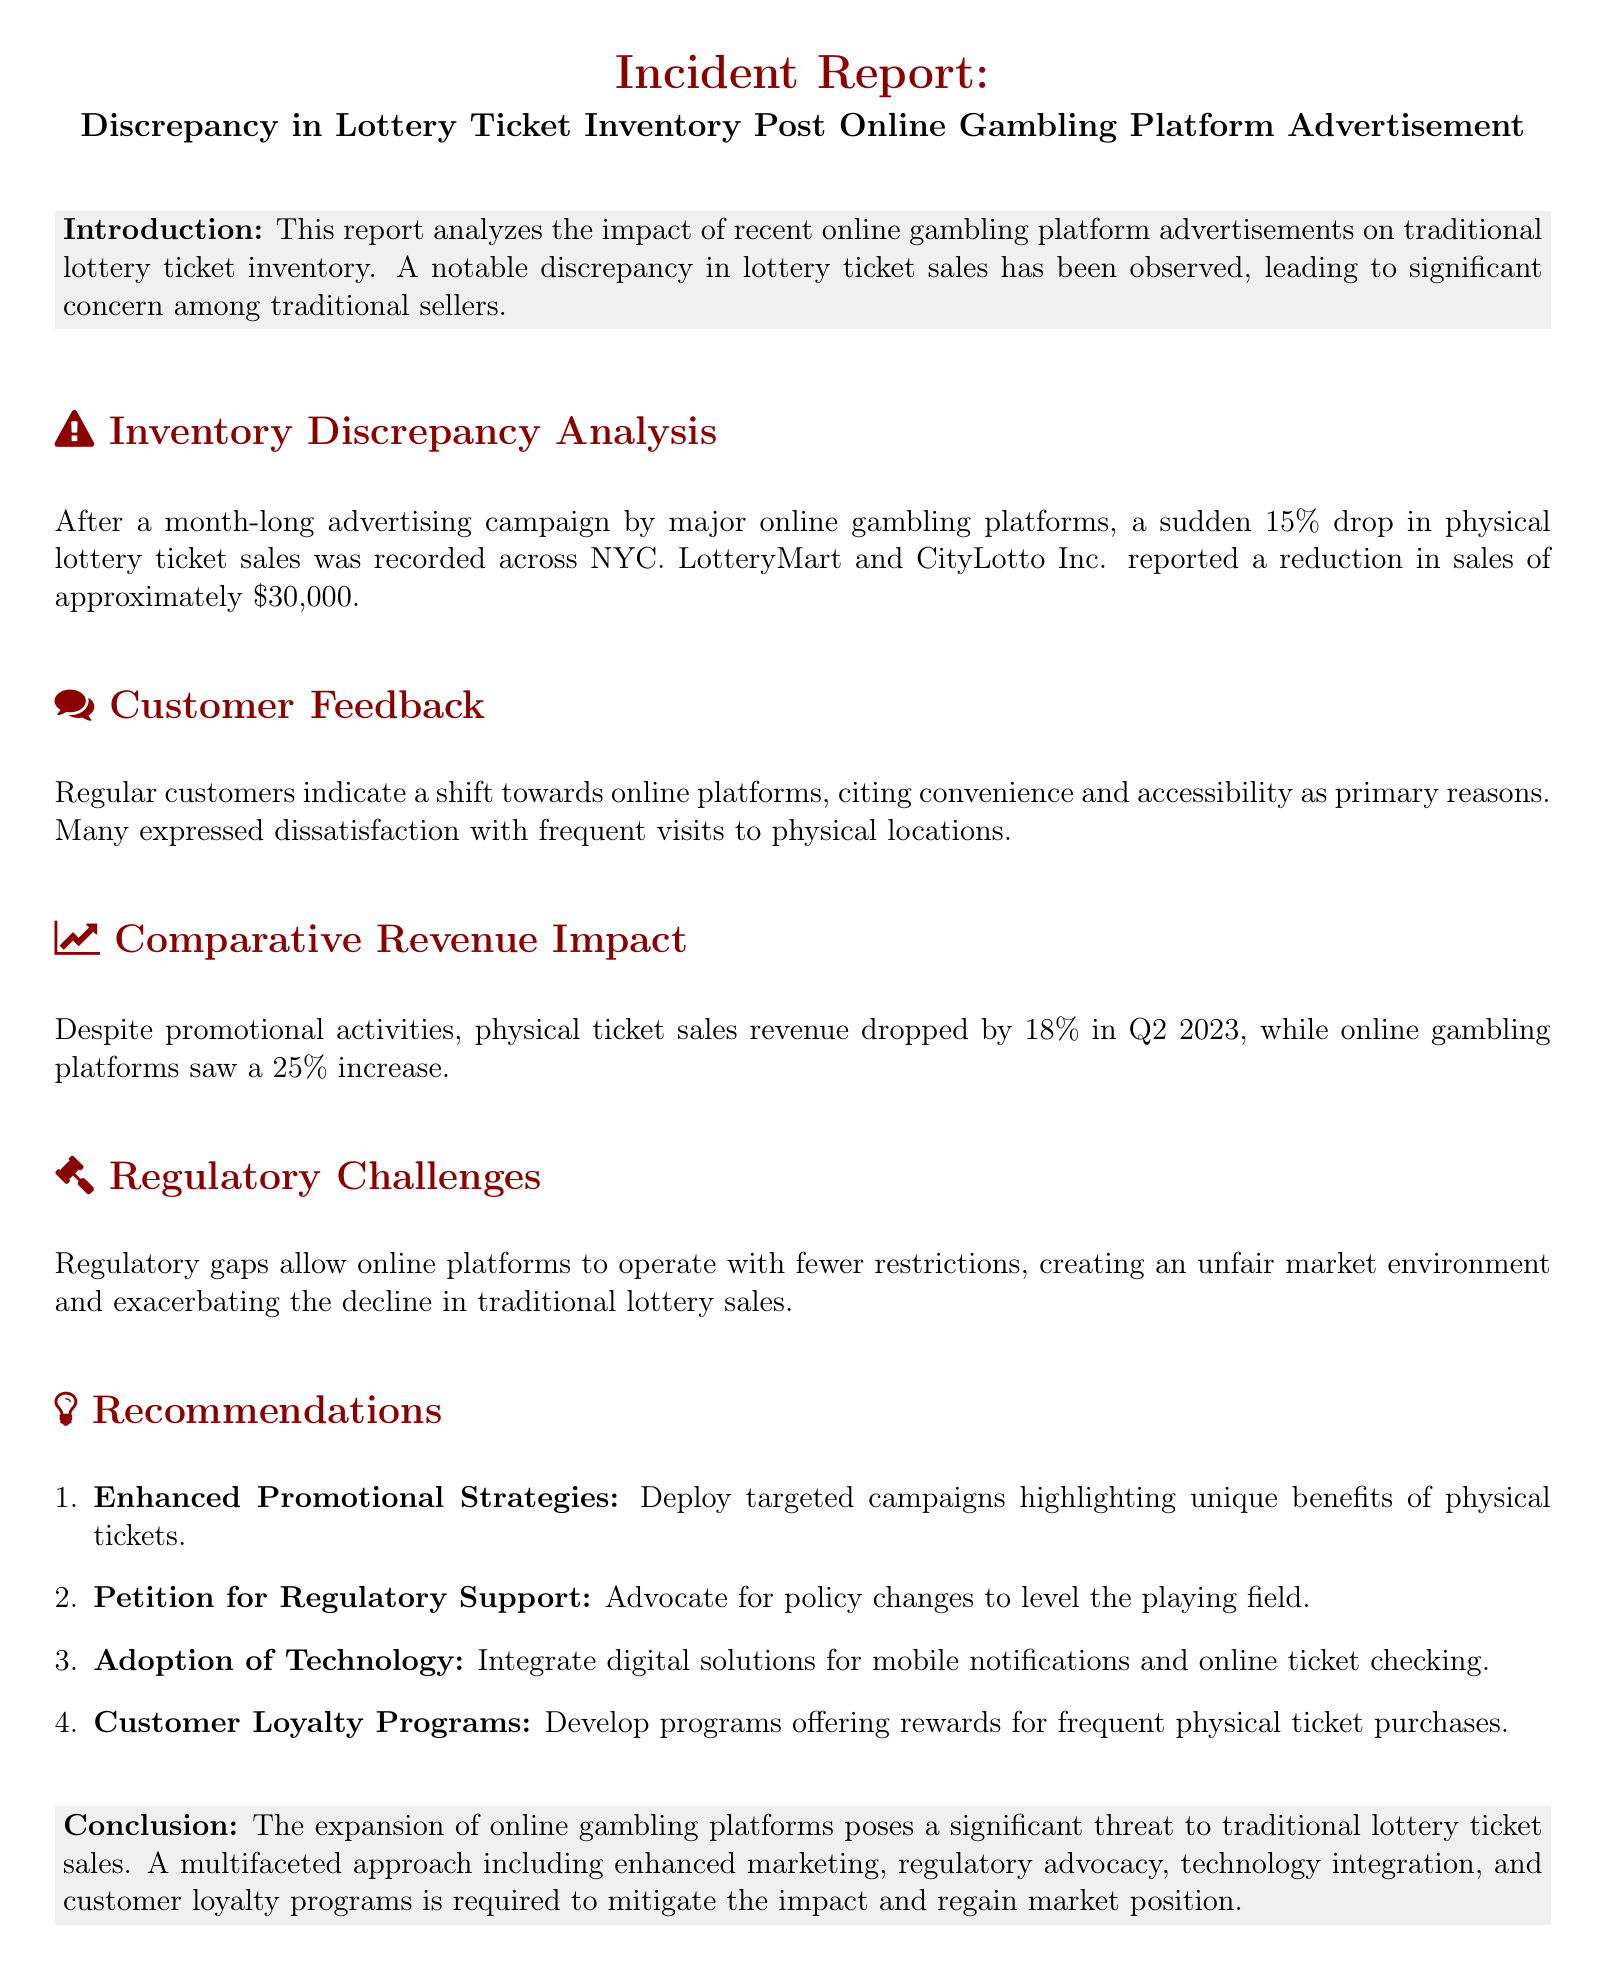What was the percentage drop in physical lottery ticket sales? The report states that there was a sudden 15% drop in physical lottery ticket sales.
Answer: 15% How much was the reduction in sales reported by LotteryMart and CityLotto Inc.? According to the report, LotteryMart and CityLotto Inc. reported a reduction in sales of approximately $30,000.
Answer: $30,000 What percentage increase did online gambling platforms see in Q2 2023? The document indicates that online gambling platforms saw a 25% increase in revenue during Q2 2023.
Answer: 25% What regulatory challenge is mentioned in relation to online gambling platforms? The report points out that regulatory gaps allow online platforms to operate with fewer restrictions, creating an unfair market environment.
Answer: Unfair market environment What is one recommendation given to enhance physical lottery ticket sales? The report recommends deploying targeted campaigns highlighting the unique benefits of physical tickets to enhance sales.
Answer: Enhanced Promotional Strategies How much did physical ticket sales revenue drop by in Q2 2023? The document states that physical ticket sales revenue dropped by 18% in Q2 2023.
Answer: 18% What primary reason did customers give for shifting to online platforms? Customers cited convenience and accessibility as primary reasons for their shift to online platforms.
Answer: Convenience and accessibility What type of programs does the report suggest to increase customer retention? It suggests developing customer loyalty programs offering rewards for frequent physical ticket purchases.
Answer: Customer Loyalty Programs What was the main threat identified to traditional lottery ticket sales? The report identifies the expansion of online gambling platforms as the main threat to traditional lottery ticket sales.
Answer: Expansion of online gambling platforms 